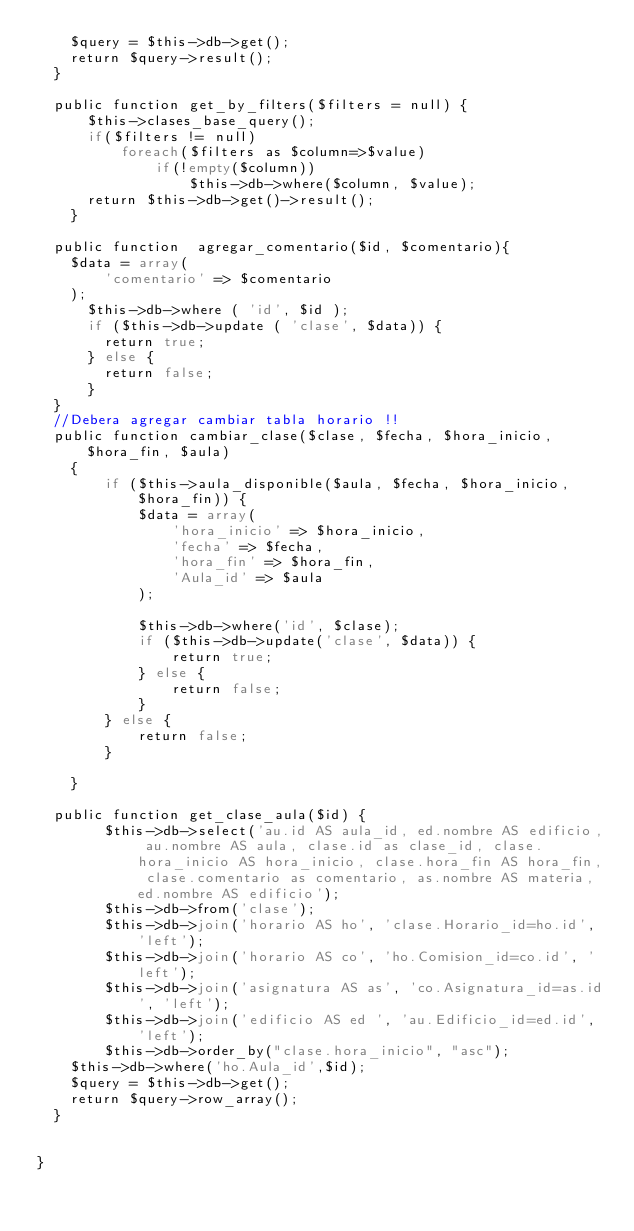<code> <loc_0><loc_0><loc_500><loc_500><_PHP_>		$query = $this->db->get();
		return $query->result();
	}

	public function get_by_filters($filters = null) {
	    $this->clases_base_query();
	    if($filters != null)
	        foreach($filters as $column=>$value)
	            if(!empty($column))
	                $this->db->where($column, $value);
	    return $this->db->get()->result();
    }
	
	public function  agregar_comentario($id, $comentario){
		$data = array(
				'comentario' => $comentario
		);
			$this->db->where ( 'id', $id );
			if ($this->db->update ( 'clase', $data)) {
				return true;
			} else {
				return false;
			}
	}
	//Debera agregar cambiar tabla horario !!
	public function cambiar_clase($clase, $fecha, $hora_inicio, $hora_fin, $aula)
    {
        if ($this->aula_disponible($aula, $fecha, $hora_inicio, $hora_fin)) {
            $data = array(
                'hora_inicio' => $hora_inicio,
                'fecha' => $fecha,
                'hora_fin' => $hora_fin,
                'Aula_id' => $aula
            );

            $this->db->where('id', $clase);
            if ($this->db->update('clase', $data)) {
                return true;
            } else {
                return false;
            }
        } else {
            return false;
        }

    }

	public function get_clase_aula($id) {
        $this->db->select('au.id AS aula_id, ed.nombre AS edificio, au.nombre AS aula, clase.id as clase_id, clase.hora_inicio AS hora_inicio, clase.hora_fin AS hora_fin, clase.comentario as comentario, as.nombre AS materia, ed.nombre AS edificio');
        $this->db->from('clase');
        $this->db->join('horario AS ho', 'clase.Horario_id=ho.id', 'left');
        $this->db->join('horario AS co', 'ho.Comision_id=co.id', 'left');
        $this->db->join('asignatura AS as', 'co.Asignatura_id=as.id', 'left');
        $this->db->join('edificio AS ed ', 'au.Edificio_id=ed.id', 'left');
        $this->db->order_by("clase.hora_inicio", "asc");
		$this->db->where('ho.Aula_id',$id);
		$query = $this->db->get();
		return $query->row_array();
	}
	
	
}</code> 